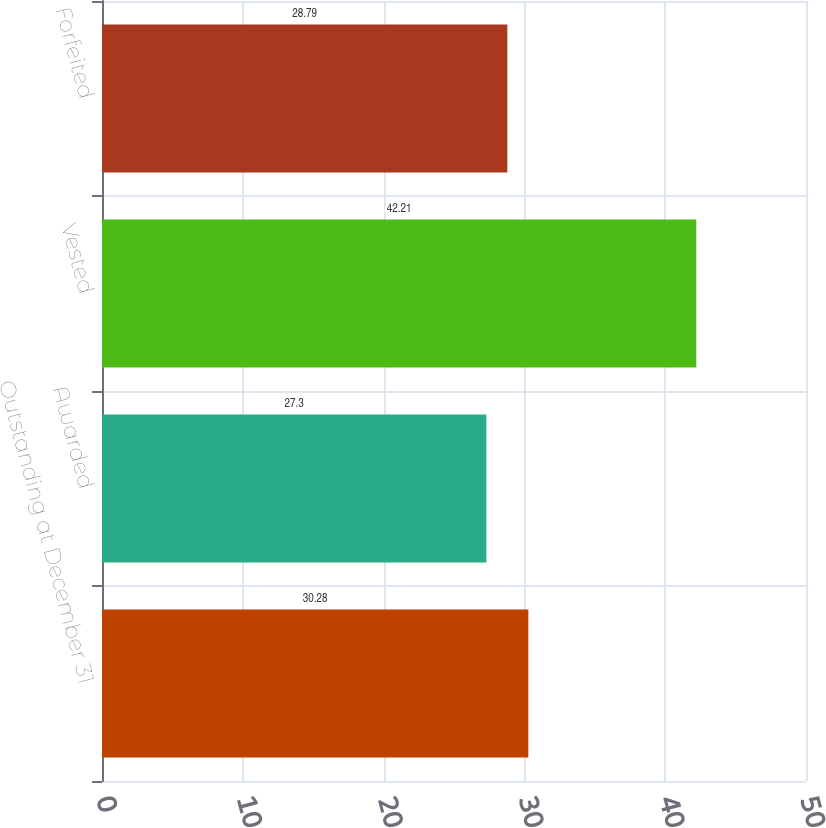Convert chart to OTSL. <chart><loc_0><loc_0><loc_500><loc_500><bar_chart><fcel>Outstanding at December 31<fcel>Awarded<fcel>Vested<fcel>Forfeited<nl><fcel>30.28<fcel>27.3<fcel>42.21<fcel>28.79<nl></chart> 